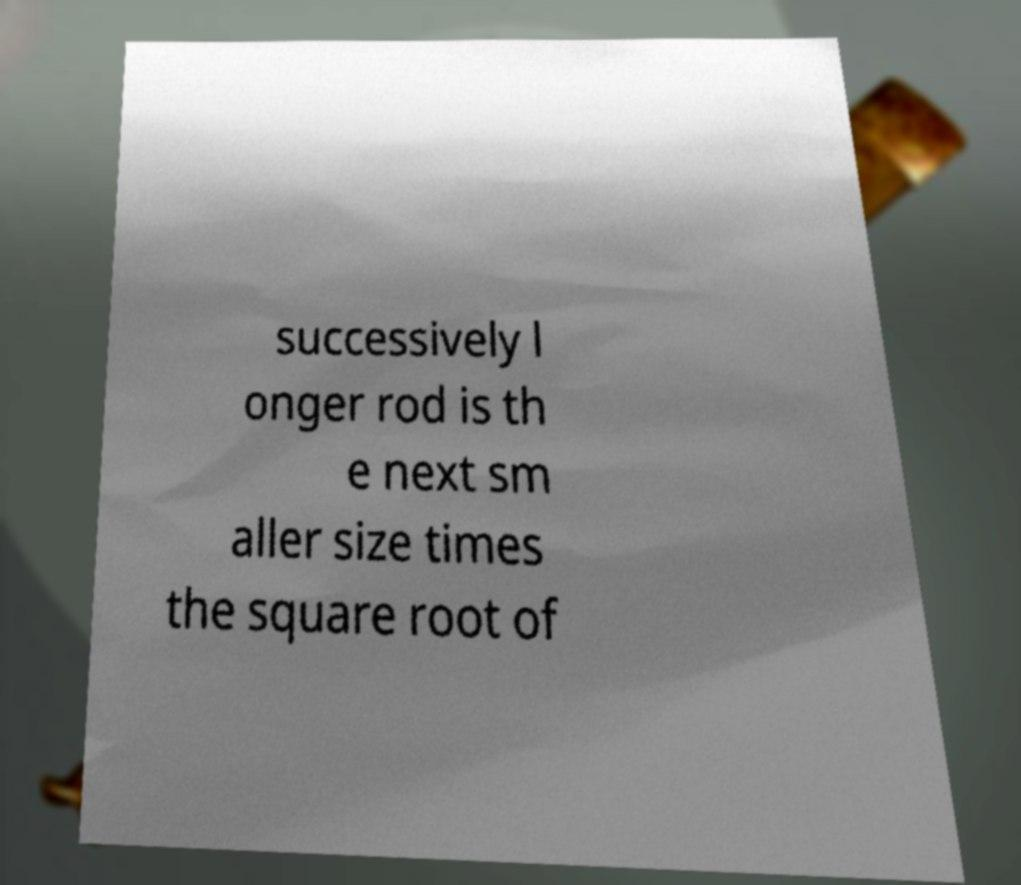I need the written content from this picture converted into text. Can you do that? successively l onger rod is th e next sm aller size times the square root of 